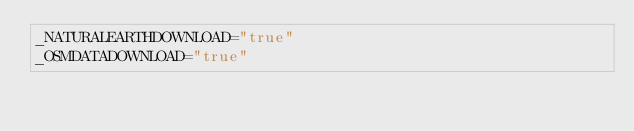Convert code to text. <code><loc_0><loc_0><loc_500><loc_500><_Bash_>_NATURALEARTHDOWNLOAD="true"
_OSMDATADOWNLOAD="true"

</code> 